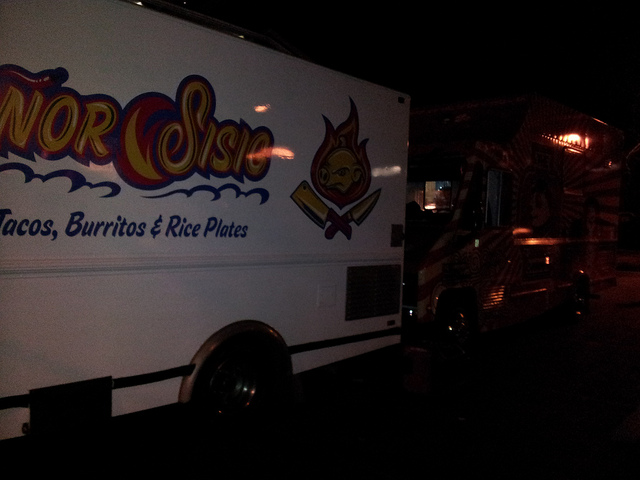Read all the text in this image. Tacos, Burritos NOR Sisio Rice Plates 